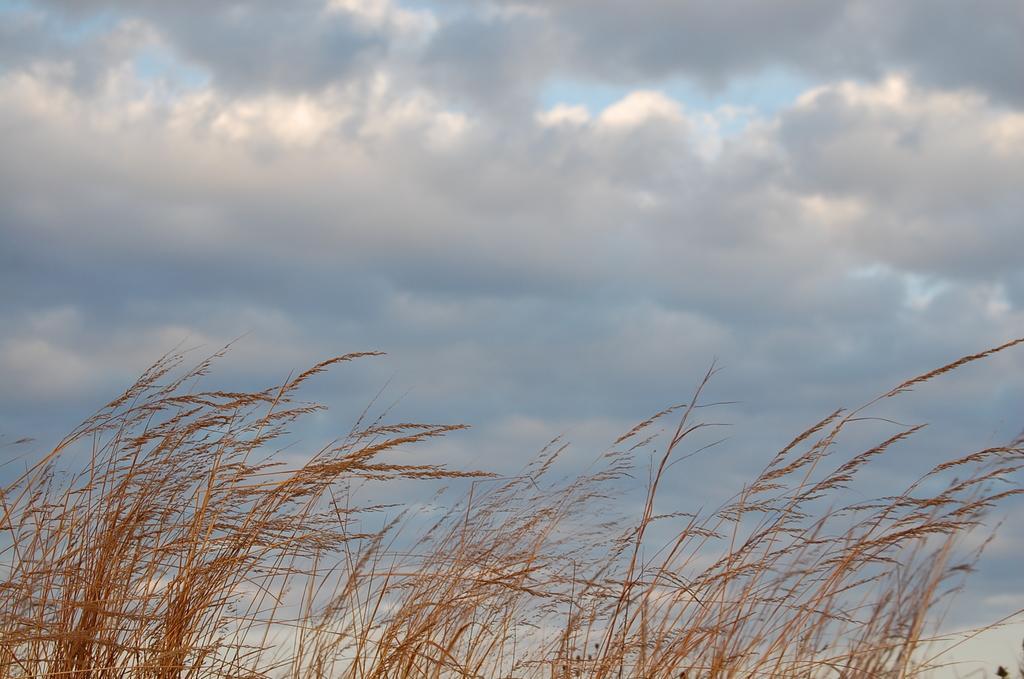Please provide a concise description of this image. In this image we can see some grass and at the top we can see the sky with clouds. 